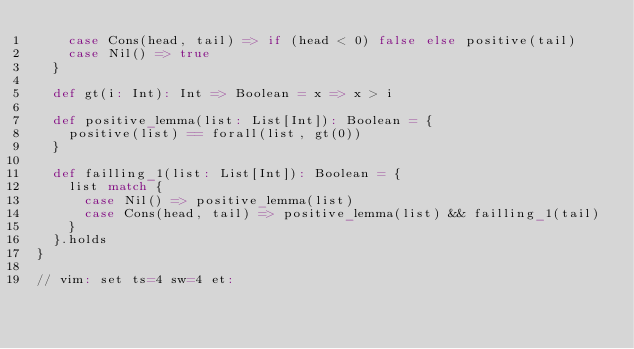Convert code to text. <code><loc_0><loc_0><loc_500><loc_500><_Scala_>    case Cons(head, tail) => if (head < 0) false else positive(tail)
    case Nil() => true
  }

  def gt(i: Int): Int => Boolean = x => x > i

  def positive_lemma(list: List[Int]): Boolean = {
    positive(list) == forall(list, gt(0))
  }

  def failling_1(list: List[Int]): Boolean = {
    list match {
      case Nil() => positive_lemma(list)
      case Cons(head, tail) => positive_lemma(list) && failling_1(tail)
    }
  }.holds
}

// vim: set ts=4 sw=4 et:
</code> 